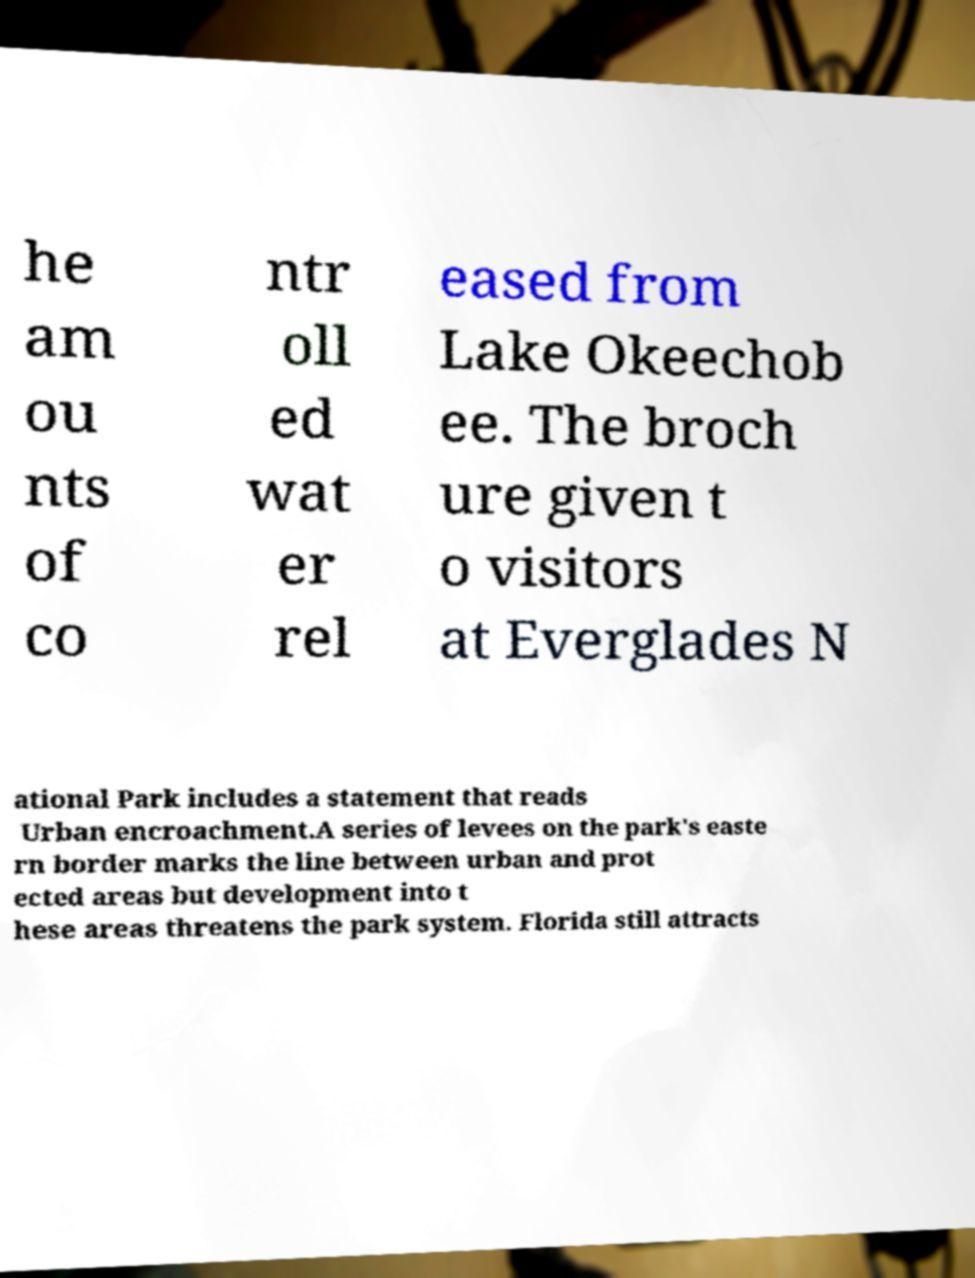There's text embedded in this image that I need extracted. Can you transcribe it verbatim? he am ou nts of co ntr oll ed wat er rel eased from Lake Okeechob ee. The broch ure given t o visitors at Everglades N ational Park includes a statement that reads Urban encroachment.A series of levees on the park's easte rn border marks the line between urban and prot ected areas but development into t hese areas threatens the park system. Florida still attracts 